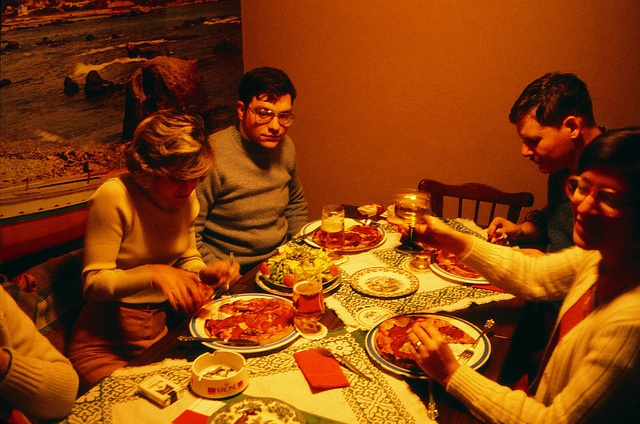Describe the objects in this image and their specific colors. I can see dining table in black, orange, red, and gold tones, people in black, orange, maroon, and red tones, people in black, maroon, and red tones, people in black, brown, maroon, and red tones, and people in black, maroon, and red tones in this image. 